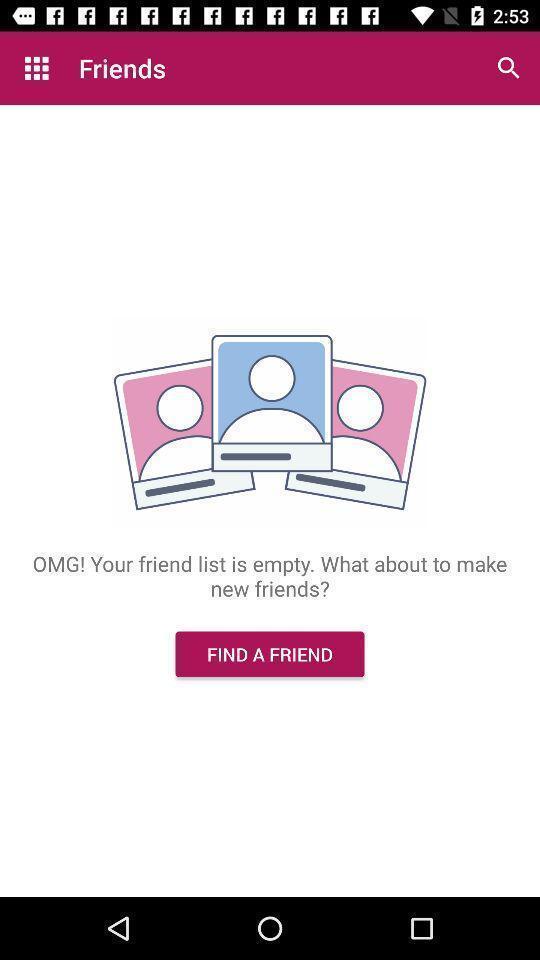What can you discern from this picture? Screen shows friends page in dating application. 